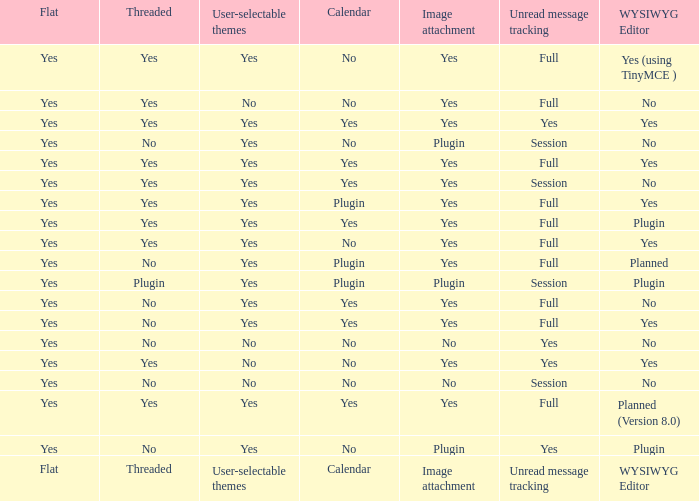Which WYSIWYG Editor has a User-selectable themes of yes, and an Unread message tracking of session, and an Image attachment of plugin? No, Plugin. 